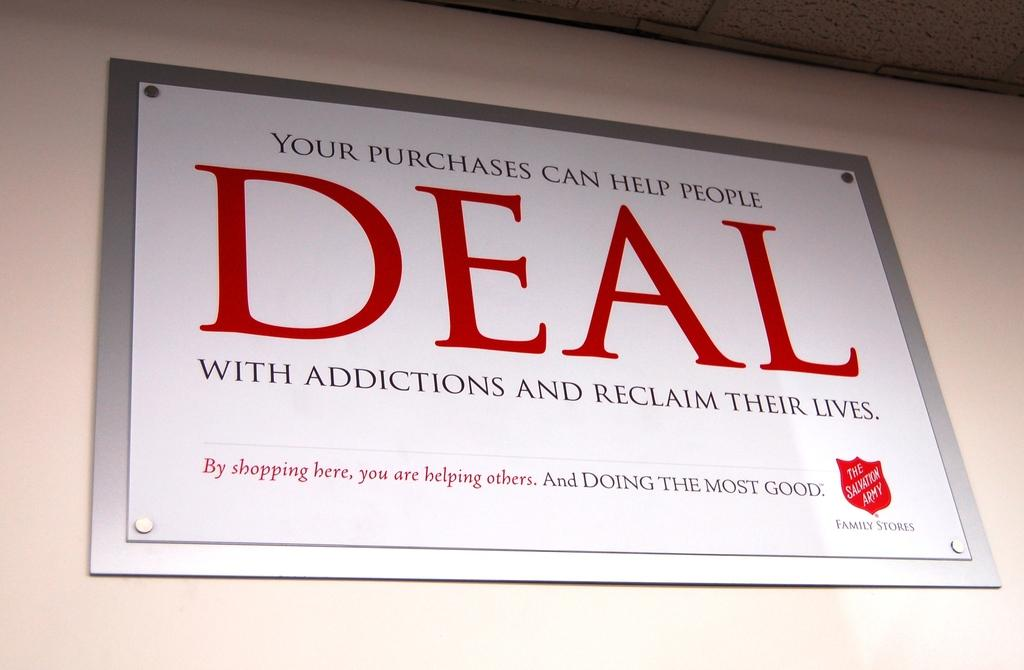<image>
Relay a brief, clear account of the picture shown. The Salvation Army sign that says, "your purchases can help people DEAL". 